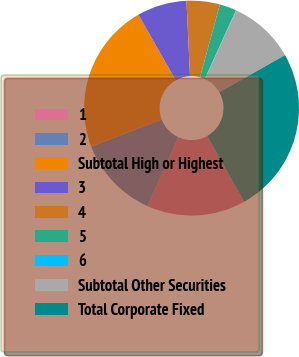<chart> <loc_0><loc_0><loc_500><loc_500><pie_chart><fcel>1<fcel>2<fcel>Subtotal High or Highest<fcel>3<fcel>4<fcel>5<fcel>6<fcel>Subtotal Other Securities<fcel>Total Corporate Fixed<nl><fcel>14.9%<fcel>12.43%<fcel>22.59%<fcel>7.48%<fcel>5.0%<fcel>2.53%<fcel>0.06%<fcel>9.95%<fcel>25.06%<nl></chart> 